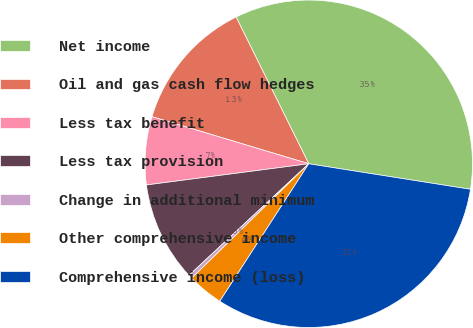<chart> <loc_0><loc_0><loc_500><loc_500><pie_chart><fcel>Net income<fcel>Oil and gas cash flow hedges<fcel>Less tax benefit<fcel>Less tax provision<fcel>Change in additional minimum<fcel>Other comprehensive income<fcel>Comprehensive income (loss)<nl><fcel>34.81%<fcel>13.04%<fcel>6.71%<fcel>9.87%<fcel>0.38%<fcel>3.54%<fcel>31.65%<nl></chart> 